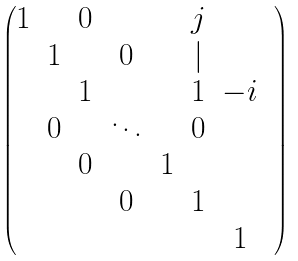Convert formula to latex. <formula><loc_0><loc_0><loc_500><loc_500>\begin{pmatrix} 1 & & 0 & & & j & & \\ & 1 & & 0 & & | & & \\ & & 1 & & & 1 & - i \\ & 0 & & \ddots & & 0 \\ & & 0 & & 1 & \\ & & & 0 & & 1 \\ & & & & & & 1 \end{pmatrix}</formula> 